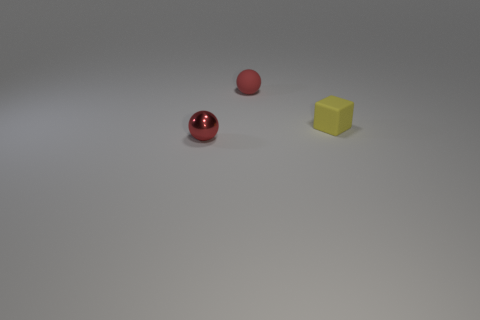Add 3 brown shiny balls. How many objects exist? 6 Subtract all cubes. How many objects are left? 2 Subtract 0 green cylinders. How many objects are left? 3 Subtract all small blocks. Subtract all small yellow rubber spheres. How many objects are left? 2 Add 3 tiny red balls. How many tiny red balls are left? 5 Add 1 small spheres. How many small spheres exist? 3 